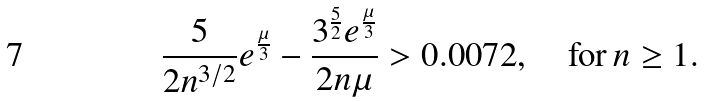Convert formula to latex. <formula><loc_0><loc_0><loc_500><loc_500>\frac { 5 } { 2 n ^ { 3 / 2 } } e ^ { \frac { \mu } { 3 } } - \frac { 3 ^ { \frac { 5 } { 2 } } e ^ { \frac { \mu } { 3 } } } { 2 n \mu } > 0 . 0 0 7 2 , \quad \text {for} \, n \geq 1 .</formula> 